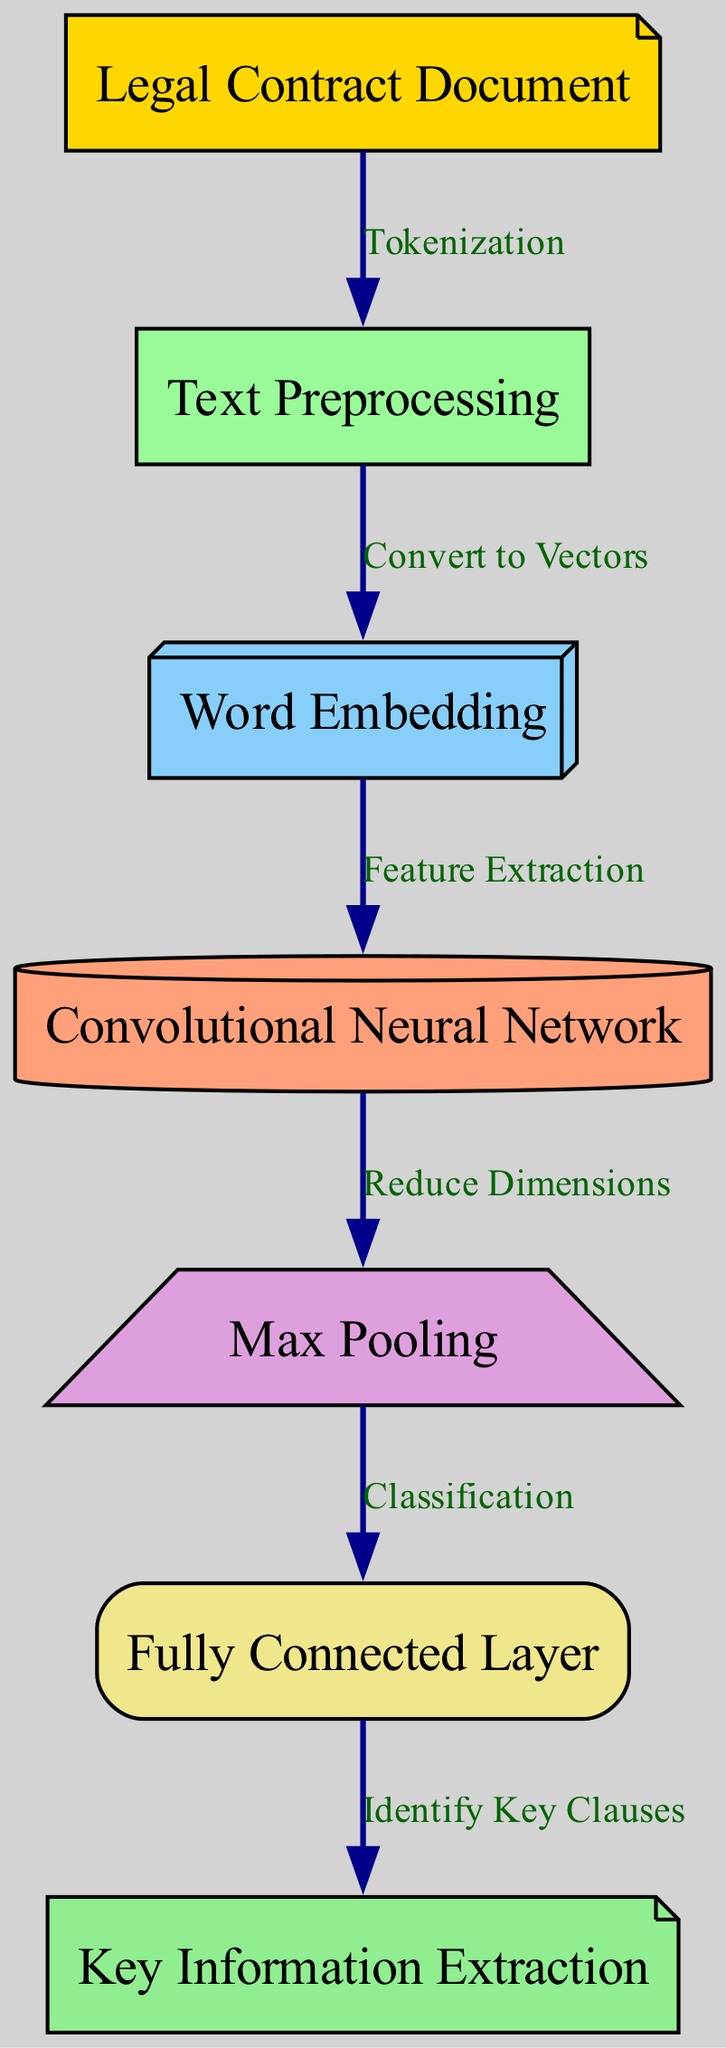What is the first step after the "Legal Contract Document"? The diagram indicates that the first step after receiving the "Legal Contract Document" is "Text Preprocessing," represented by an edge connecting these two nodes.
Answer: Text Preprocessing How many nodes are present in the diagram? By counting each unique node listed in the diagram, there are a total of seven nodes involved in the process.
Answer: Seven What does the "Max Pooling" node do? The "Max Pooling" node is connected to "Convolutional Neural Network" indicating it functions to "Reduce Dimensions," which is the role it plays in the overall process.
Answer: Reduce Dimensions Which nodes are directly connected to the "Convolutional Neural Network"? The "Convolutional Neural Network" node is directly connected to two other nodes: "Word Embedding," which provides input for feature extraction, and "Max Pooling," which reduces dimensions after processing.
Answer: Word Embedding and Max Pooling What is the final output of this diagram? The last node in the flow, which concludes the process, is "Key Information Extraction," indicating that this is the final output generated by the entire system.
Answer: Key Information Extraction What transformation occurs from "Text Preprocessing" to "Word Embedding"? The transformation from "Text Preprocessing" to "Word Embedding" is labeled as "Convert to Vectors," showing how processed text is represented as numerical data for further processing.
Answer: Convert to Vectors How many edges are there in the diagram? Counting the edges between the nodes that show the flow of processing, there are a total of six edges that connect the various stages of the neural network process.
Answer: Six What is the role of the "Fully Connected Layer"? The "Fully Connected Layer" in the diagram plays the role of "Classification," where the features extracted are classified for identifying key clauses in the legal documents.
Answer: Classification 